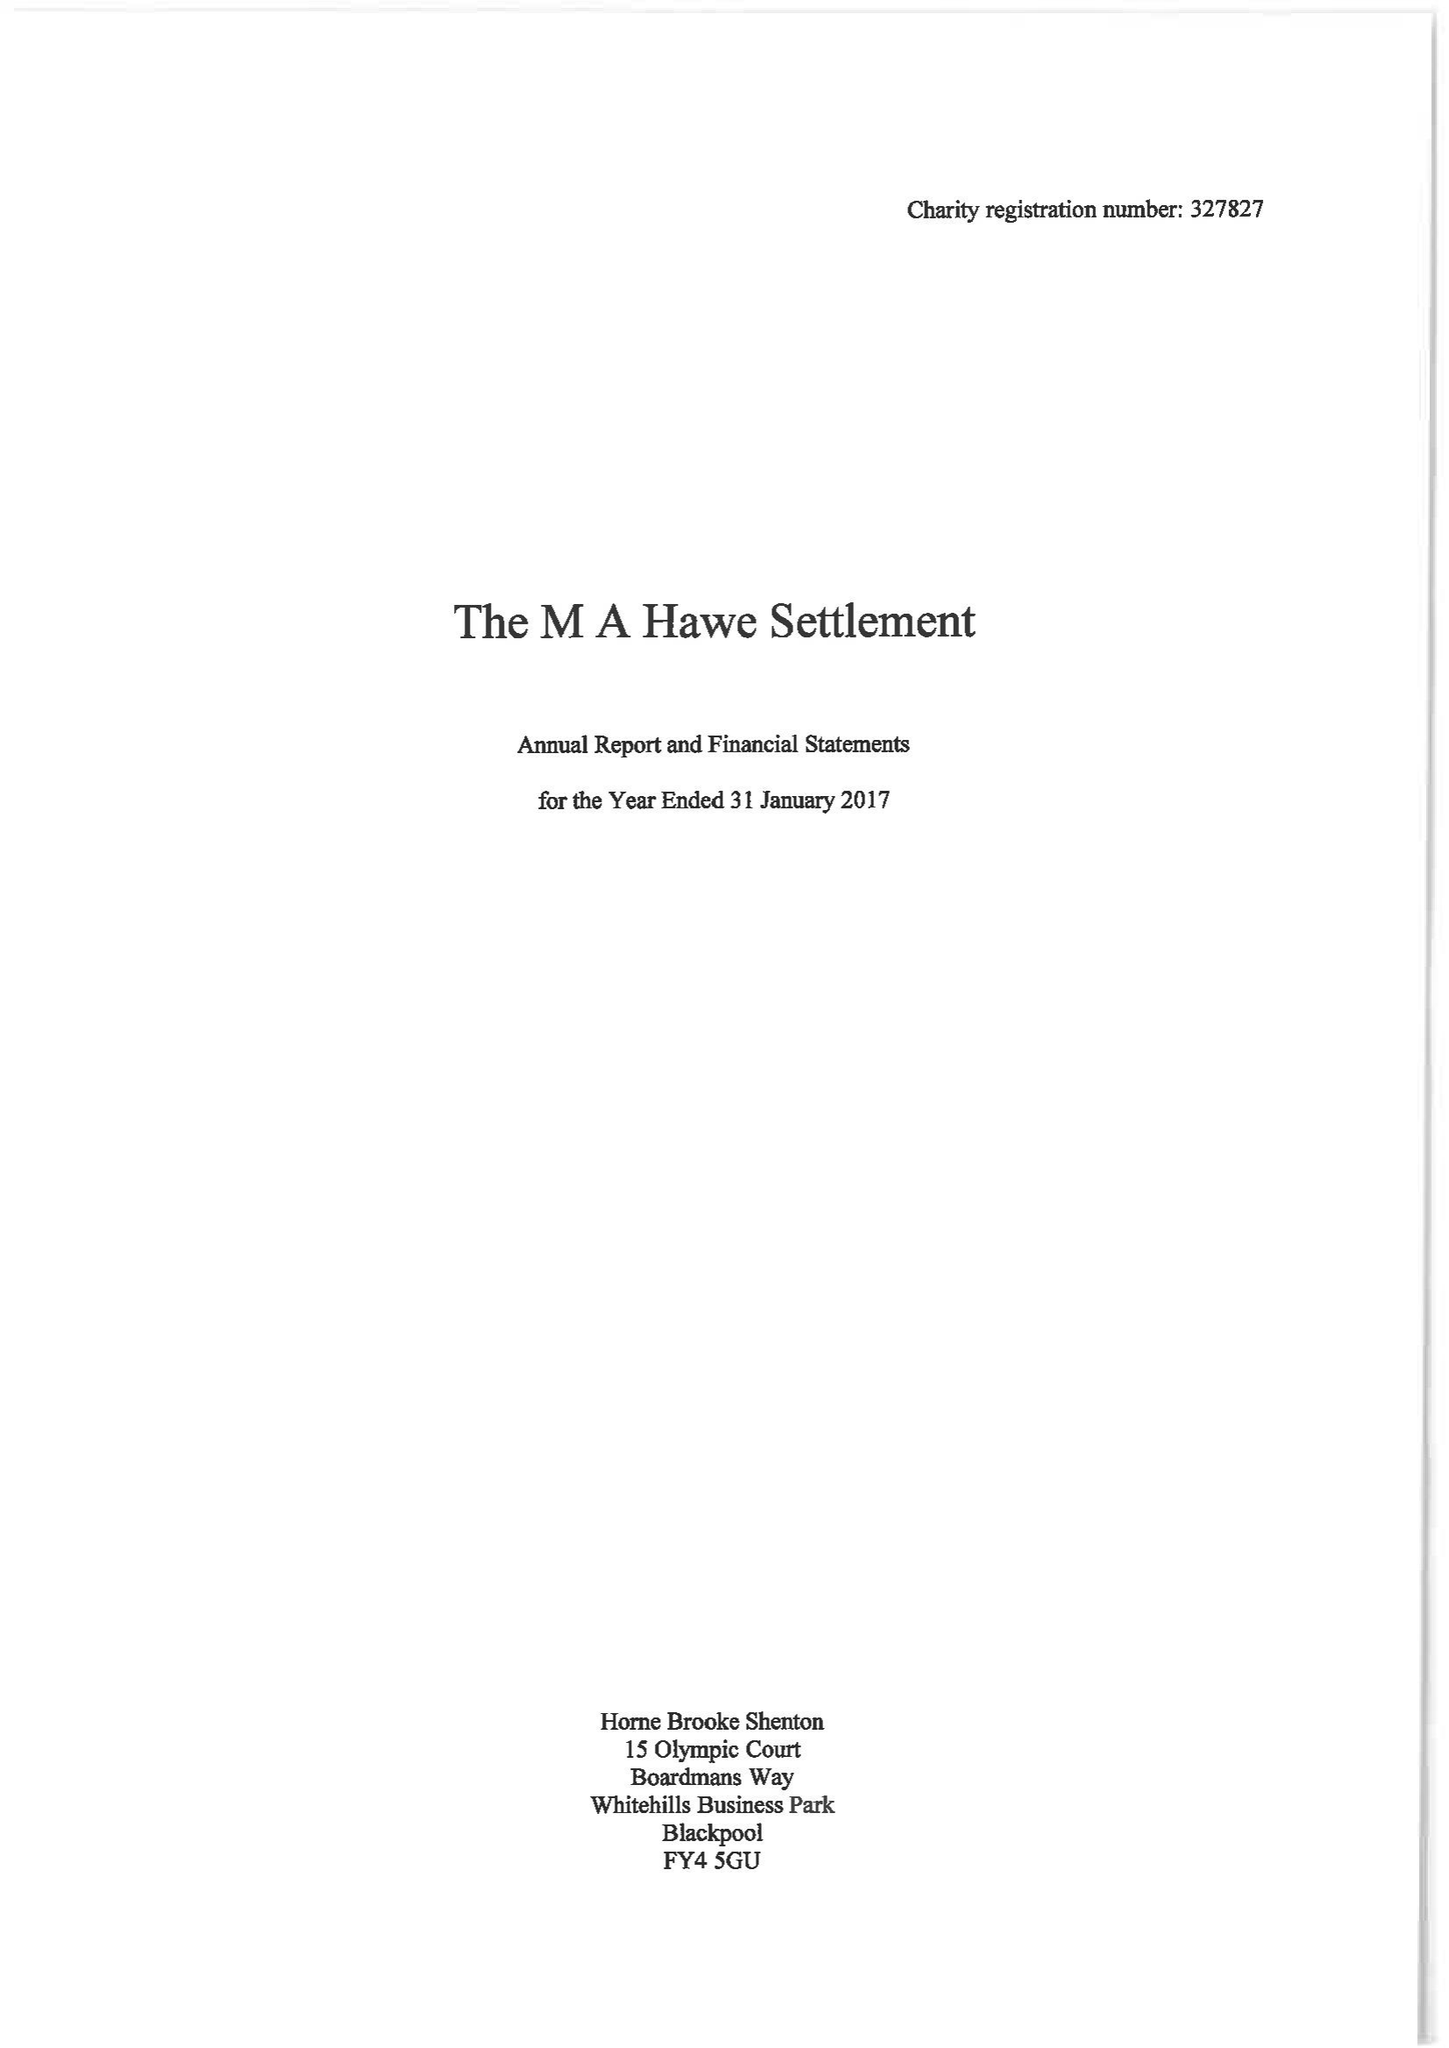What is the value for the address__street_line?
Answer the question using a single word or phrase. 94 PARK VIEW ROAD 